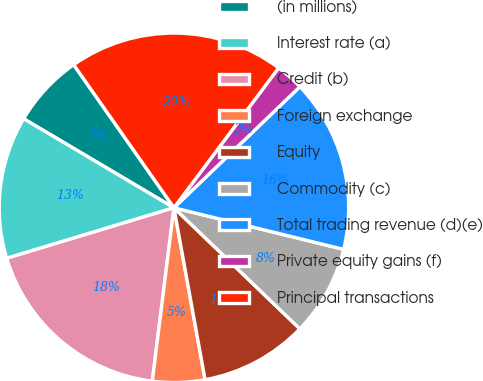<chart> <loc_0><loc_0><loc_500><loc_500><pie_chart><fcel>(in millions)<fcel>Interest rate (a)<fcel>Credit (b)<fcel>Foreign exchange<fcel>Equity<fcel>Commodity (c)<fcel>Total trading revenue (d)(e)<fcel>Private equity gains (f)<fcel>Principal transactions<nl><fcel>6.76%<fcel>13.18%<fcel>18.35%<fcel>4.83%<fcel>9.96%<fcel>8.36%<fcel>16.01%<fcel>2.59%<fcel>19.95%<nl></chart> 